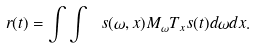Convert formula to latex. <formula><loc_0><loc_0><loc_500><loc_500>r ( t ) = \int \int \ s ( \omega , x ) M _ { \omega } T _ { x } s ( t ) d \omega d x .</formula> 